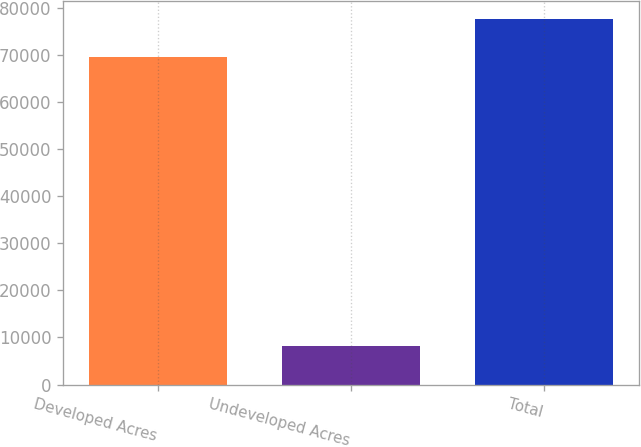<chart> <loc_0><loc_0><loc_500><loc_500><bar_chart><fcel>Developed Acres<fcel>Undeveloped Acres<fcel>Total<nl><fcel>69558<fcel>8129<fcel>77687<nl></chart> 